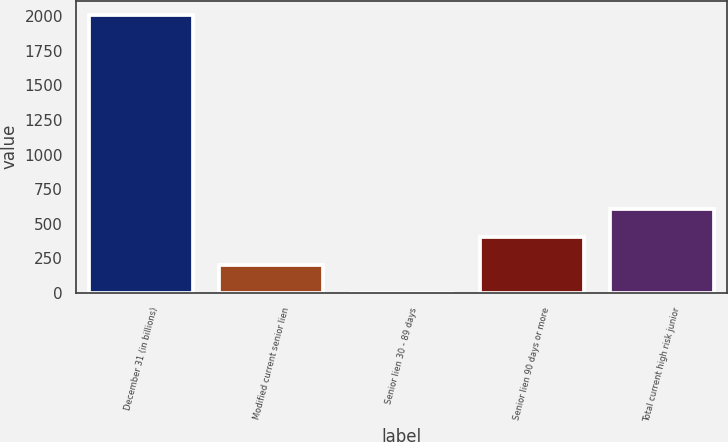<chart> <loc_0><loc_0><loc_500><loc_500><bar_chart><fcel>December 31 (in billions)<fcel>Modified current senior lien<fcel>Senior lien 30 - 89 days<fcel>Senior lien 90 days or more<fcel>Total current high risk junior<nl><fcel>2012<fcel>202.01<fcel>0.9<fcel>403.12<fcel>604.23<nl></chart> 